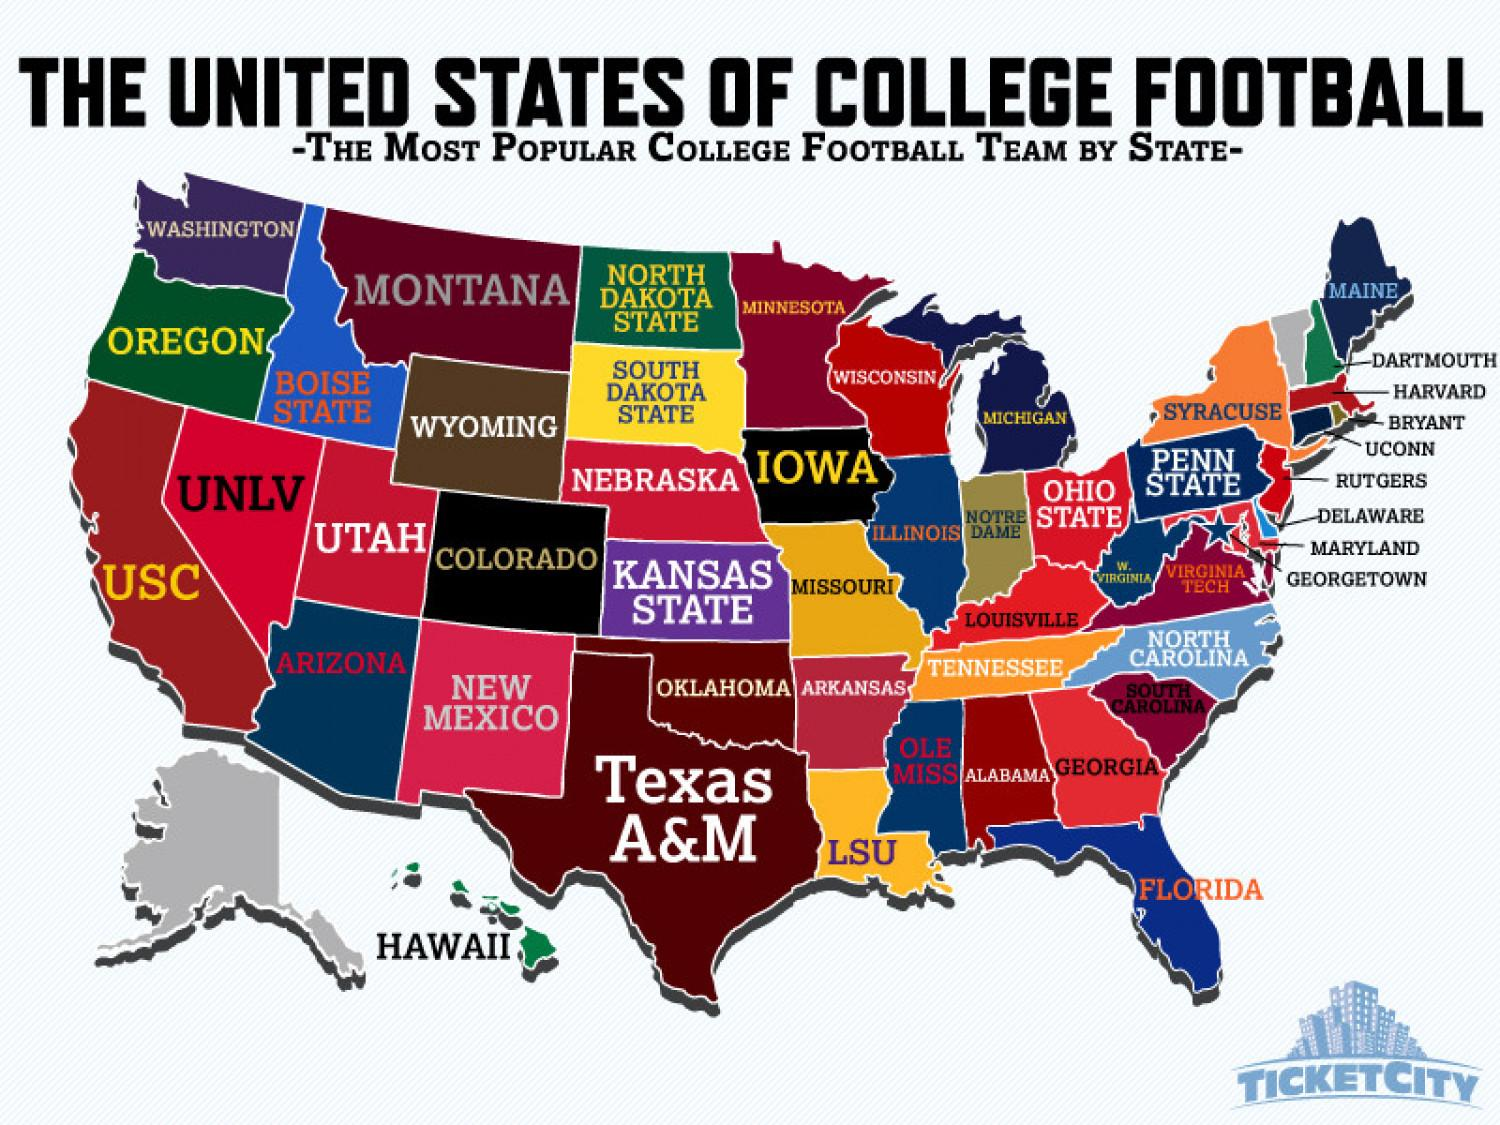Draw attention to some important aspects in this diagram. Syracuse is the most popular college football team in New York. Rutgers is the most popular college football team in the state of New Jersey. Harvard is the most popular college football team in the state of Massachusetts. The Boise State college football team is the most popular in the state of Idaho. The most popular college football team in California is USC. 